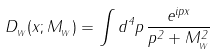<formula> <loc_0><loc_0><loc_500><loc_500>D _ { _ { W } } ( x ; M _ { _ { W } } ) = \int d ^ { 4 } p \, \frac { e ^ { i p x } } { p ^ { 2 } + M _ { _ { W } } ^ { 2 } }</formula> 